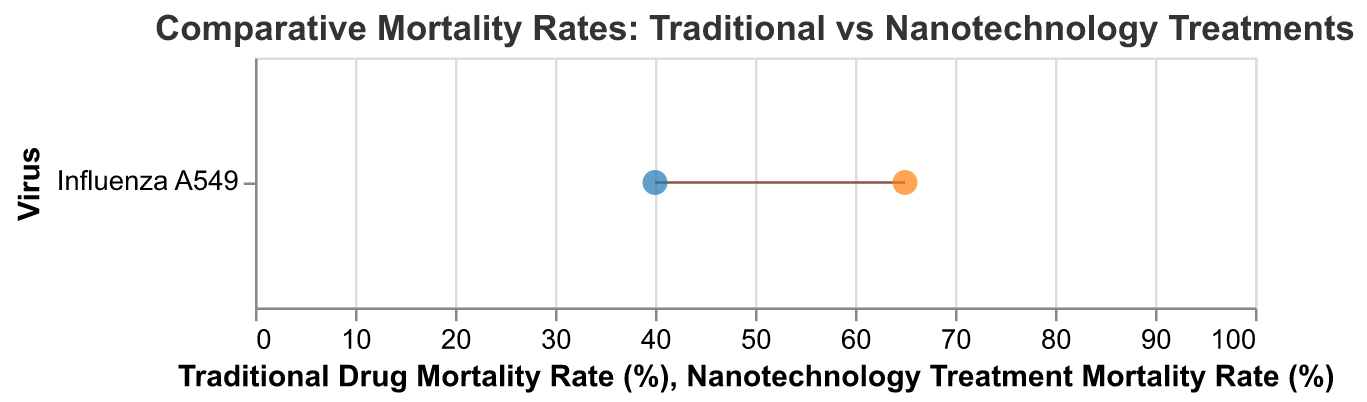What is the title of the figure? The title is displayed at the top of the chart and is easily visible. It provides a summary of the data being presented.
Answer: Comparative Mortality Rates: Traditional vs Nanotechnology Treatments What cell type is used in the study? The cell type is mentioned in the data and is part of the description for the virus. It can be found alongside the virus name.
Answer: Human Lung Epithelial Cells What is the mortality rate for traditional drug treatment? The mortality rate for traditional drug treatment is shown on the left end of the dumbbell plot for each virus.
Answer: 40% What is the mortality rate for nanotechnology treatment? The mortality rate for nanotechnology treatment is shown on the right end of the dumbbell plot for each virus.
Answer: 65% Which treatment shows a higher mortality rate for Influenza A549? By comparing the two ends of the dumbbell plot for Influenza A549, the treatment with a higher mortality rate can be identified.
Answer: Nanotechnology Treatment How much higher is the mortality rate for the nanotechnology treatment compared to the traditional drug for Influenza A549? To find out the increase, subtract the traditional drug mortality rate from the nanotechnology treatment mortality rate. Specifically, 65% - 40%.
Answer: 25% What is the range of mortality rates shown on the x-axis? The range is provided by the labels and ticks on the x-axis, indicating the minimum and maximum values.
Answer: 0% to 100% How many viruses are being compared in the figure? Each virus corresponds to a unique dumbbell, and the number can be determined by counting these points.
Answer: 1 What color represents the points for traditional drug mortality rates, and what color represents nanotechnology treatment mortality rates? The colors used for the different points are visually distinct and can be identified by looking at the legend or the points themselves.
Answer: Traditional: blue, Nanotechnology: orange 